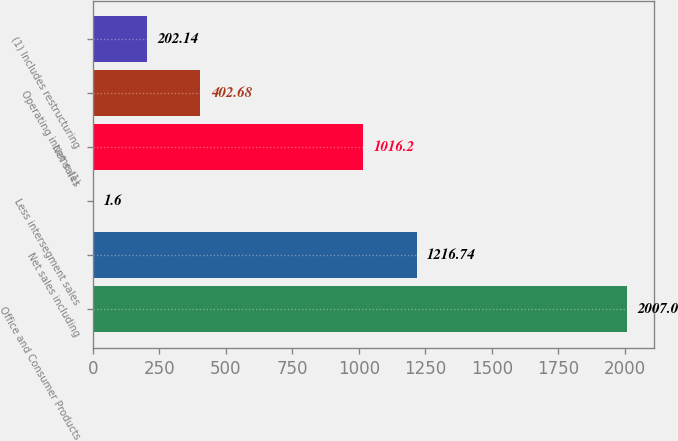Convert chart to OTSL. <chart><loc_0><loc_0><loc_500><loc_500><bar_chart><fcel>Office and Consumer Products<fcel>Net sales including<fcel>Less intersegment sales<fcel>Net sales<fcel>Operating income (1)<fcel>(1) Includes restructuring<nl><fcel>2007<fcel>1216.74<fcel>1.6<fcel>1016.2<fcel>402.68<fcel>202.14<nl></chart> 